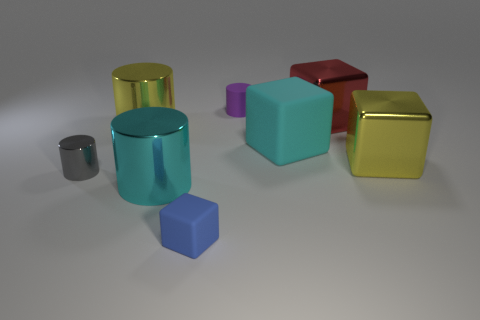Does the yellow shiny thing left of the cyan metal thing have the same shape as the cyan object that is in front of the small gray shiny cylinder?
Your response must be concise. Yes. There is a yellow shiny object that is to the right of the purple matte thing left of the block that is behind the large yellow cylinder; how big is it?
Ensure brevity in your answer.  Large. What is the size of the matte object in front of the tiny gray metallic thing?
Offer a terse response. Small. What is the material of the cube behind the big cyan rubber thing?
Provide a short and direct response. Metal. What number of brown objects are metal objects or cylinders?
Ensure brevity in your answer.  0. Is the material of the yellow cube the same as the tiny object that is behind the gray cylinder?
Offer a very short reply. No. Is the number of small purple cylinders behind the purple rubber thing the same as the number of yellow objects that are behind the tiny gray thing?
Offer a very short reply. No. There is a blue rubber thing; does it have the same size as the cylinder to the right of the tiny blue cube?
Offer a very short reply. Yes. Are there more tiny objects left of the purple matte cylinder than small blue rubber blocks?
Offer a terse response. Yes. What number of other objects are the same size as the purple thing?
Make the answer very short. 2. 